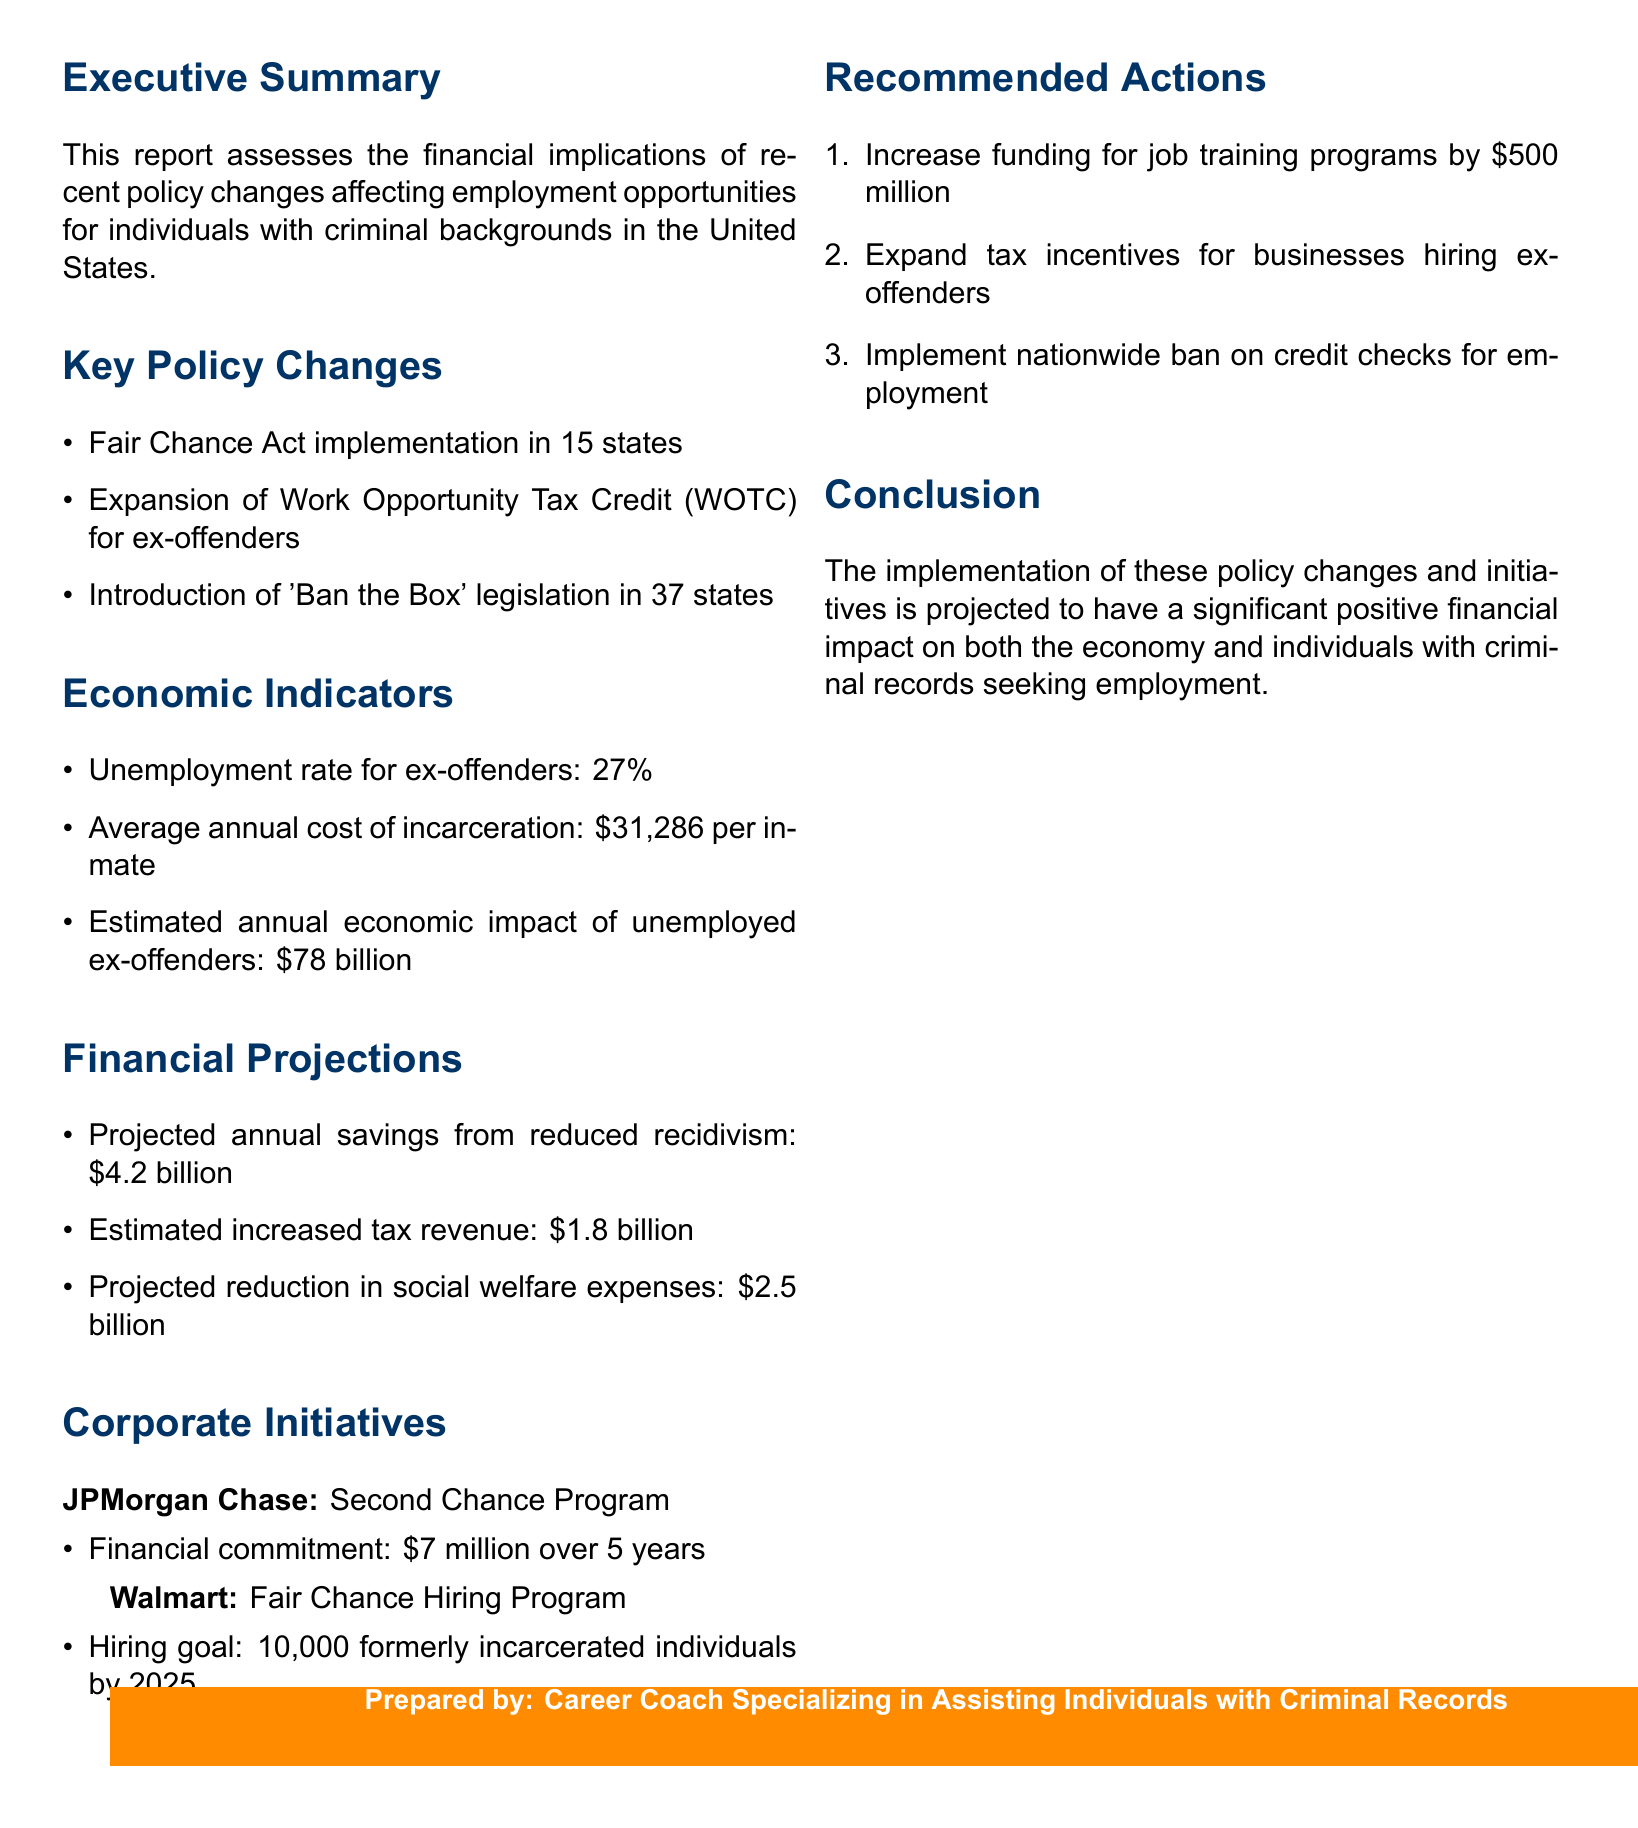What is the unemployment rate for ex-offenders? This information is found in the economic indicators section of the report.
Answer: 27% What is the financial commitment of JPMorgan Chase's Second Chance Program? This is detailed under corporate initiatives, specifically regarding financial commitments made by corporations.
Answer: $7 million over 5 years How much are the projected annual savings from reduced recidivism? This figure is mentioned in the financial projections section, highlighting economic benefits.
Answer: $4.2 billion How many states have implemented 'Ban the Box' legislation? This information is included in the key policy changes section of the report.
Answer: 37 states What is the estimated annual economic impact of unemployed ex-offenders? This data point is listed under economic indicators and reflects a significant financial issue.
Answer: $78 billion Which expected action involves increasing funding by $500 million? This action is found in the recommended actions section, focusing on financial improvements for job training.
Answer: Increase funding for job training programs What is Walmart's hiring goal for formerly incarcerated individuals by 2025? This is specified in the corporate initiatives section regarding Walmart’s Fair Chance Hiring Program.
Answer: 10,000 individuals What is the estimated increased tax revenue from the policy changes? This financial projection figure is provided within the financial projections section, indicating potential government benefits.
Answer: $1.8 billion 